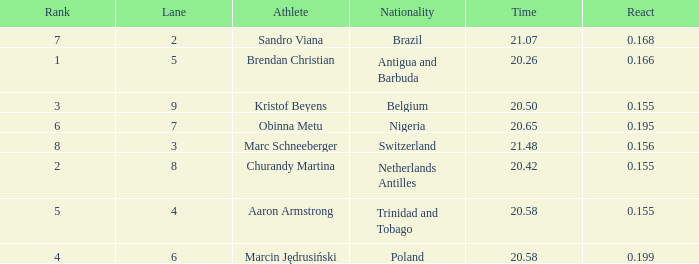How much Time has a Reaction of 0.155, and an Athlete of kristof beyens, and a Rank smaller than 3? 0.0. 